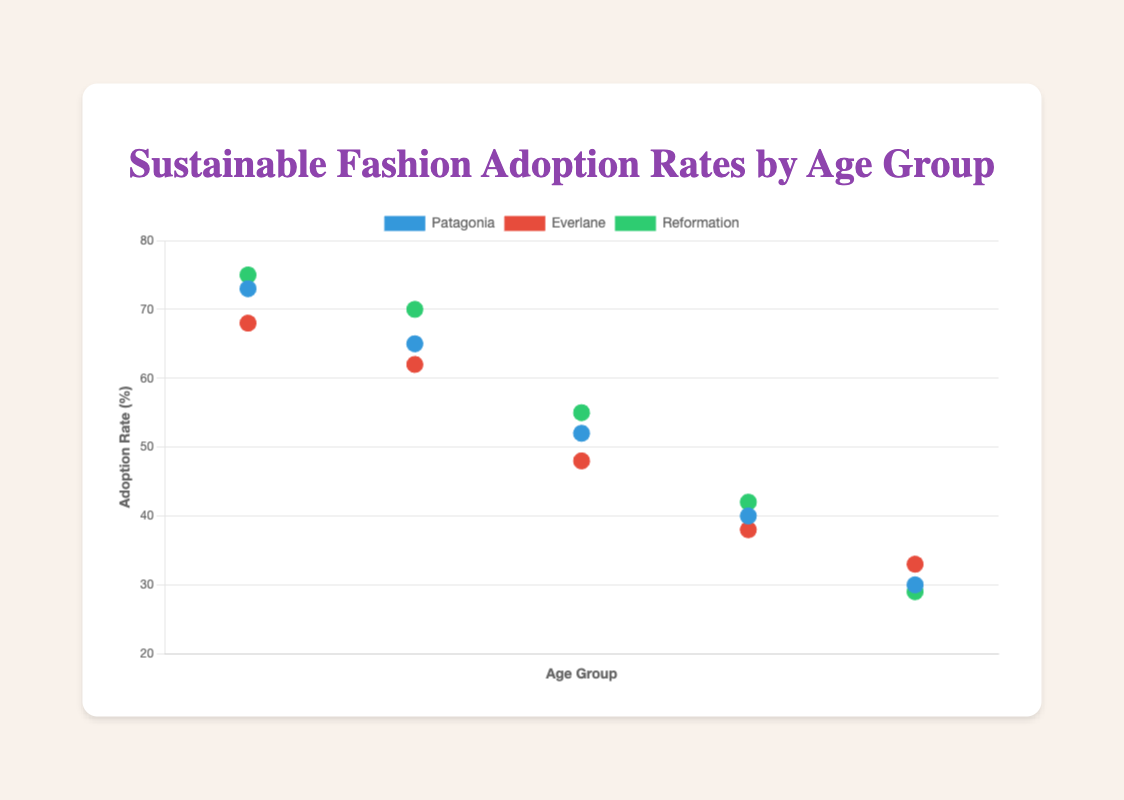What is the title of the chart? Look at the top of the chart where the main heading is located.
Answer: Sustainable Fashion Adoption Rates by Age Group Which age group has the highest adoption rate for sustainable fashion? By examining the y-axis values, the highest adoption rate for sustainable fashion is seen in the 18-25 age group.
Answer: 18-25 Which brand has the highest adoption rate in the 60+ age group? Locate '60+' on the x-axis and find the highest point in terms of y-axis value corresponding to 'Patagonia', 'Everlane', and 'Reformation'. 'Everlane' has the highest adoption rate in the 60+ age group.
Answer: Everlane How does the adoption rate of Everlane change with increasing age groups? Observe the y-axis values for 'Everlane' across different age groups: 68 (18-25), 62 (26-35), 48 (36-45), 38 (46-60), and 33 (60+). The adoption rate consistently decreases with increasing age groups.
Answer: It decreases What is the difference in adoption rates between Patagonia and Reformation in the 36-45 age group? Find the y-axis values for Patagonia (52) and Reformation (55) in the 36-45 age group. Calculate the difference: 55 - 52.
Answer: 3 Which age group shows the biggest gap in adoption rates between the highest and lowest brands? Evaluate the differences between the highest and lowest adoption rates across age groups: 
18-25 (75-68=7), 
26-35 (70-62=8), 
36-45 (55-48=7), 
46-60 (42-38=4), 
60+ (33-29=4). The biggest gap is in the 26-35 age group.
Answer: 26-35 Which brand performs the best overall across all age groups? Summarize the total adoption rates for each brand across all age groups:
Patagonia (73+65+52+40+30=260), 
Everlane (68+62+48+38+33=249), 
Reformation (75+70+55+42+29=271). Reformation has the highest total adoption rate.
Answer: Reformation What is the average adoption rate of Reformation for age groups 18-45? Calculate the average for Reformation's adoption rates for 18-45: (75+70+55)/3 = 200/3 = 66.67.
Answer: 66.67 Between which age groups does the adoption rate for Patagonia drop the most sharply? Compare the drops between successive age groups for Patagonia:
18-25 to 26-35 (73-65=8), 
26-35 to 36-45 (65-52=13), 
36-45 to 46-60 (52-40=12), 
46-60 to 60+ (40-30=10). The sharpest drop is between the 26-35 and 36-45 age groups.
Answer: 26-35 to 36-45 